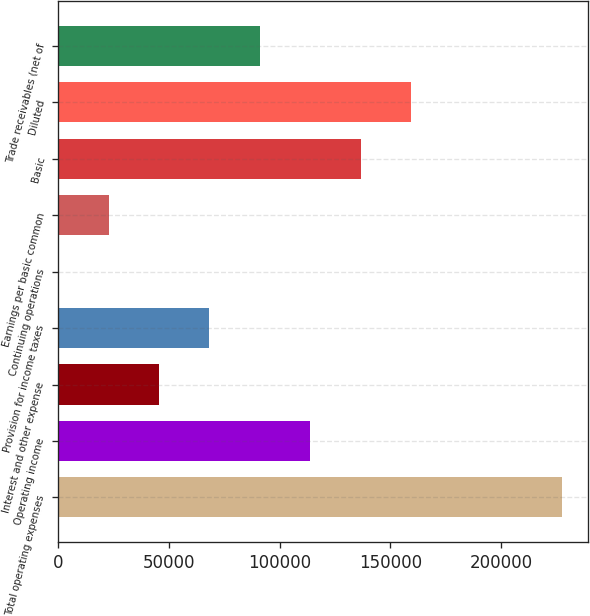<chart> <loc_0><loc_0><loc_500><loc_500><bar_chart><fcel>Total operating expenses<fcel>Operating income<fcel>Interest and other expense<fcel>Provision for income taxes<fcel>Continuing operations<fcel>Earnings per basic common<fcel>Basic<fcel>Diluted<fcel>Trade receivables (net of<nl><fcel>227649<fcel>113825<fcel>45530.4<fcel>68295.2<fcel>0.76<fcel>22765.6<fcel>136590<fcel>159354<fcel>91060<nl></chart> 